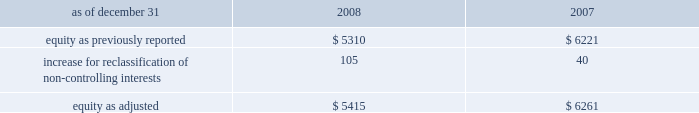The company recognizes the effect of income tax positions only if sustaining those positions is more likely than not .
Changes in recognition or measurement are reflected in the period in which a change in judgment occurs .
The company records penalties and interest related to unrecognized tax benefits in income taxes in the company 2019s consolidated statements of income .
Changes in accounting principles business combinations and noncontrolling interests on january 1 , 2009 , the company adopted revised principles related to business combinations and noncontrolling interests .
The revised principle on business combinations applies to all transactions or other events in which an entity obtains control over one or more businesses .
It requires an acquirer to recognize the assets acquired , the liabilities assumed , and any noncontrolling interest in the acquiree at the acquisition date , measured at their fair values as of that date .
Business combinations achieved in stages require recognition of the identifiable assets and liabilities , as well as the noncontrolling interest in the acquiree , at the full amounts of their fair values when control is obtained .
This revision also changes the requirements for recognizing assets acquired and liabilities assumed arising from contingencies , and requires direct acquisition costs to be expensed .
In addition , it provides certain changes to income tax accounting for business combinations which apply to both new and previously existing business combinations .
In april 2009 , additional guidance was issued which revised certain business combination guidance related to accounting for contingent liabilities assumed in a business combination .
The company has adopted this guidance in conjunction with the adoption of the revised principles related to business combinations .
The adoption of the revised principles related to business combinations has not had a material impact on the consolidated financial statements .
The revised principle related to noncontrolling interests establishes accounting and reporting standards for the noncontrolling interests in a subsidiary and for the deconsolidation of a subsidiary .
The revised principle clarifies that a noncontrolling interest in a subsidiary is an ownership interest in the consolidated entity that should be reported as a separate component of equity in the consolidated statements of financial position .
The revised principle requires retrospective adjustments , for all periods presented , of stockholders 2019 equity and net income for noncontrolling interests .
In addition to these financial reporting changes , the revised principle provides for significant changes in accounting related to changes in ownership of noncontrolling interests .
Changes in aon 2019s controlling financial interests in consolidated subsidiaries that do not result in a loss of control are accounted for as equity transactions similar to treasury stock transactions .
If a change in ownership of a consolidated subsidiary results in a loss of control and deconsolidation , any retained ownership interests are remeasured at fair value with the gain or loss reported in net income .
In previous periods , noncontrolling interests for operating subsidiaries were reported in other general expenses in the consolidated statements of income .
Prior period amounts have been restated to conform to the current year 2019s presentation .
The principal effect on the prior years 2019 balance sheets related to the adoption of the new guidance related to noncontrolling interests is summarized as follows ( in millions ) : .
The revised principle also requires that net income be adjusted to include the net income attributable to the noncontrolling interests and a new separate caption for net income attributable to aon stockholders be presented in the consolidated statements of income .
The adoption of this new guidance increased net income by $ 16 million and $ 13 million for 2008 and 2007 , respectively .
Net .
What was the percentage change in the reclassification of non-controlling interests from 2007 to 2008? 
Rationale: the reclassification of non-controlling interests increased by 162.5% from 2007 to 2008
Computations: ((105 - 40) / 40)
Answer: 1.625. 